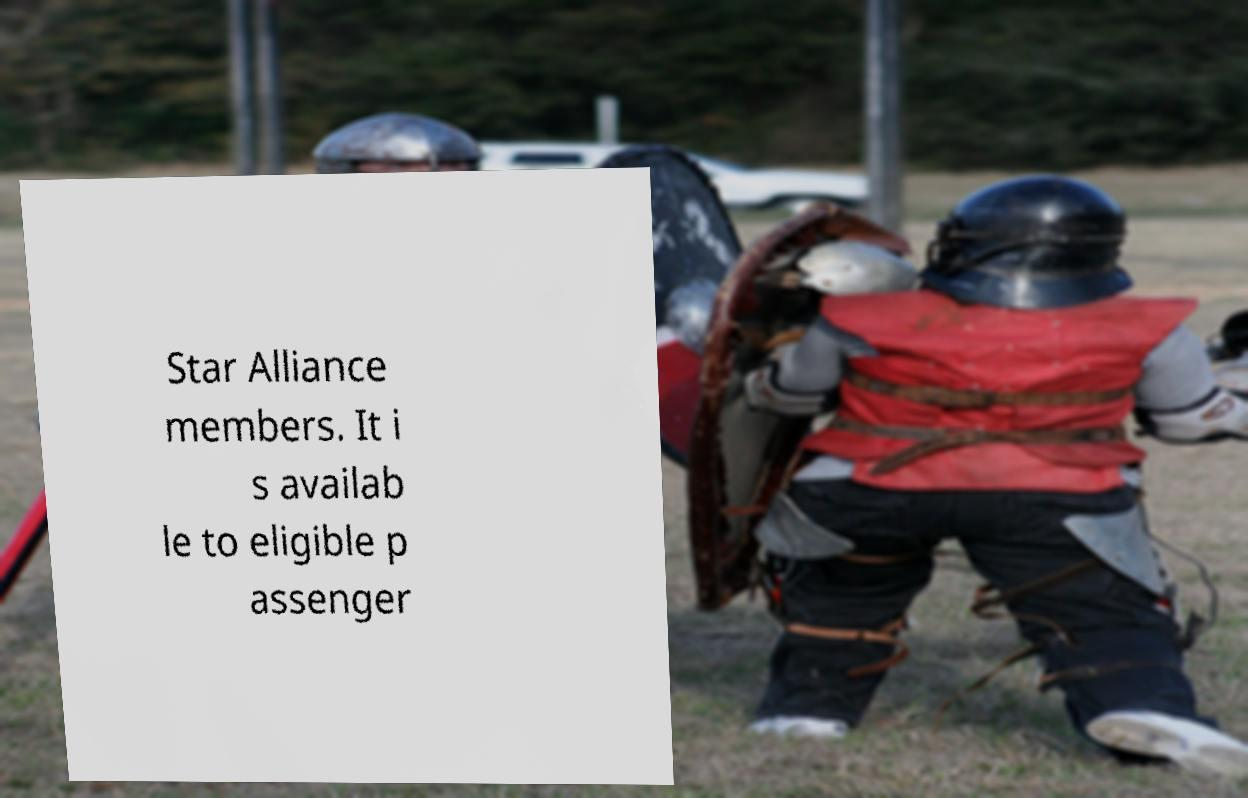I need the written content from this picture converted into text. Can you do that? Star Alliance members. It i s availab le to eligible p assenger 